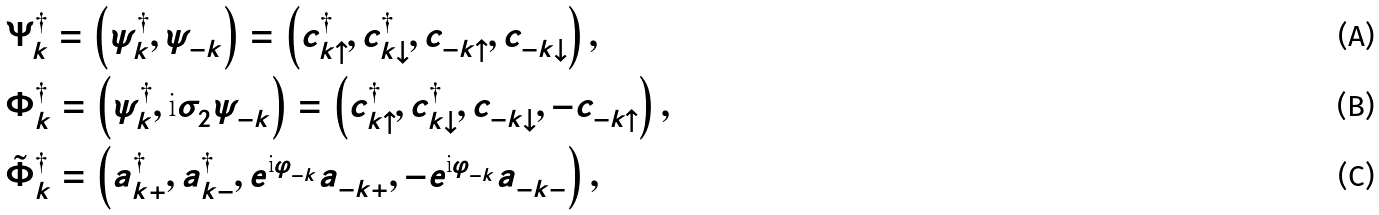<formula> <loc_0><loc_0><loc_500><loc_500>& \Psi ^ { \dag } _ { k } = \left ( \psi ^ { \dag } _ { k } , \psi ^ { \ } _ { - k } \right ) = \left ( c ^ { \dag } _ { k \uparrow } , c ^ { \dag } _ { k \downarrow } , c ^ { \ } _ { - k \uparrow } , c ^ { \ } _ { - k \downarrow } \right ) , \\ & \Phi ^ { \dag } _ { k } = \left ( \psi ^ { \dag } _ { k } , \text {i} \sigma ^ { \ } _ { 2 } \psi ^ { \ } _ { - k } \right ) = \left ( c ^ { \dag } _ { k \uparrow } , c ^ { \dag } _ { k \downarrow } , c ^ { \ } _ { - k \downarrow } , - c ^ { \ } _ { - k \uparrow } \right ) , \\ & \tilde { \Phi } ^ { \dag } _ { k } = \left ( a ^ { \dag } _ { k + } , a ^ { \dag } _ { k - } , e ^ { \text {i} \varphi ^ { \ } _ { - k } } a ^ { \ } _ { - k + } , - e ^ { \text {i} \varphi ^ { \ } _ { - k } } a ^ { \ } _ { - k - } \right ) ,</formula> 